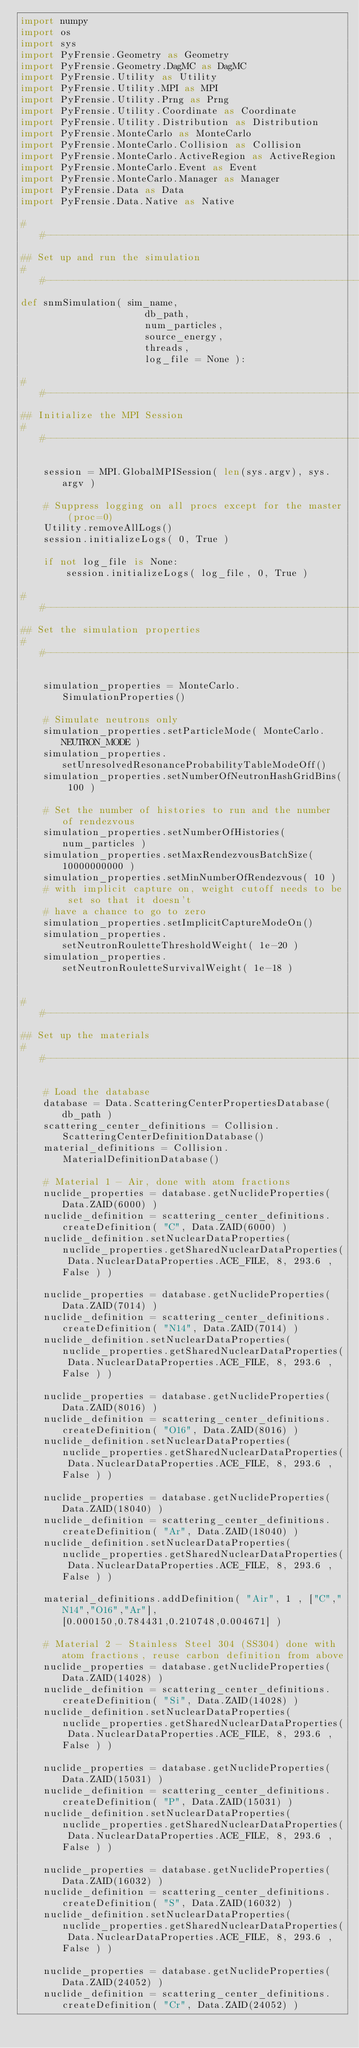<code> <loc_0><loc_0><loc_500><loc_500><_Python_>import numpy
import os
import sys
import PyFrensie.Geometry as Geometry
import PyFrensie.Geometry.DagMC as DagMC
import PyFrensie.Utility as Utility
import PyFrensie.Utility.MPI as MPI
import PyFrensie.Utility.Prng as Prng
import PyFrensie.Utility.Coordinate as Coordinate
import PyFrensie.Utility.Distribution as Distribution
import PyFrensie.MonteCarlo as MonteCarlo
import PyFrensie.MonteCarlo.Collision as Collision
import PyFrensie.MonteCarlo.ActiveRegion as ActiveRegion
import PyFrensie.MonteCarlo.Event as Event
import PyFrensie.MonteCarlo.Manager as Manager
import PyFrensie.Data as Data
import PyFrensie.Data.Native as Native

##---------------------------------------------------------------------------##
## Set up and run the simulation
##---------------------------------------------------------------------------##
def snmSimulation( sim_name,
                      db_path,
                      num_particles,
                      source_energy,
                      threads,
                      log_file = None ):
    
##---------------------------------------------------------------------------##
## Initialize the MPI Session
##---------------------------------------------------------------------------##
    
    session = MPI.GlobalMPISession( len(sys.argv), sys.argv )
    
    # Suppress logging on all procs except for the master (proc=0)
    Utility.removeAllLogs()
    session.initializeLogs( 0, True )
    
    if not log_file is None:
        session.initializeLogs( log_file, 0, True )
    
##---------------------------------------------------------------------------##
## Set the simulation properties
##---------------------------------------------------------------------------##
    
    simulation_properties = MonteCarlo.SimulationProperties()
    
    # Simulate neutrons only
    simulation_properties.setParticleMode( MonteCarlo.NEUTRON_MODE )
    simulation_properties.setUnresolvedResonanceProbabilityTableModeOff()
    simulation_properties.setNumberOfNeutronHashGridBins( 100 ) 
    
    # Set the number of histories to run and the number of rendezvous
    simulation_properties.setNumberOfHistories( num_particles )
    simulation_properties.setMaxRendezvousBatchSize( 10000000000 )
    simulation_properties.setMinNumberOfRendezvous( 10 )
    # with implicit capture on, weight cutoff needs to be set so that it doesn't 
    # have a chance to go to zero
    simulation_properties.setImplicitCaptureModeOn()
    simulation_properties.setNeutronRouletteThresholdWeight( 1e-20 )
    simulation_properties.setNeutronRouletteSurvivalWeight( 1e-18 )

    
##---------------------------------------------------------------------------##
## Set up the materials
##---------------------------------------------------------------------------##

    # Load the database
    database = Data.ScatteringCenterPropertiesDatabase( db_path )
    scattering_center_definitions = Collision.ScatteringCenterDefinitionDatabase()
    material_definitions = Collision.MaterialDefinitionDatabase()

    # Material 1 - Air, done with atom fractions
    nuclide_properties = database.getNuclideProperties( Data.ZAID(6000) )
    nuclide_definition = scattering_center_definitions.createDefinition( "C", Data.ZAID(6000) )
    nuclide_definition.setNuclearDataProperties( nuclide_properties.getSharedNuclearDataProperties( Data.NuclearDataProperties.ACE_FILE, 8, 293.6 , False ) )

    nuclide_properties = database.getNuclideProperties( Data.ZAID(7014) )
    nuclide_definition = scattering_center_definitions.createDefinition( "N14", Data.ZAID(7014) )
    nuclide_definition.setNuclearDataProperties( nuclide_properties.getSharedNuclearDataProperties( Data.NuclearDataProperties.ACE_FILE, 8, 293.6 , False ) )

    nuclide_properties = database.getNuclideProperties( Data.ZAID(8016) )
    nuclide_definition = scattering_center_definitions.createDefinition( "O16", Data.ZAID(8016) )
    nuclide_definition.setNuclearDataProperties( nuclide_properties.getSharedNuclearDataProperties( Data.NuclearDataProperties.ACE_FILE, 8, 293.6 , False ) )

    nuclide_properties = database.getNuclideProperties( Data.ZAID(18040) )
    nuclide_definition = scattering_center_definitions.createDefinition( "Ar", Data.ZAID(18040) )
    nuclide_definition.setNuclearDataProperties( nuclide_properties.getSharedNuclearDataProperties( Data.NuclearDataProperties.ACE_FILE, 8, 293.6 , False ) )

    material_definitions.addDefinition( "Air", 1 , ["C","N14","O16","Ar"], [0.000150,0.784431,0.210748,0.004671] )

    # Material 2 - Stainless Steel 304 (SS304) done with atom fractions, reuse carbon definition from above
    nuclide_properties = database.getNuclideProperties( Data.ZAID(14028) )
    nuclide_definition = scattering_center_definitions.createDefinition( "Si", Data.ZAID(14028) )
    nuclide_definition.setNuclearDataProperties( nuclide_properties.getSharedNuclearDataProperties( Data.NuclearDataProperties.ACE_FILE, 8, 293.6 , False ) )

    nuclide_properties = database.getNuclideProperties( Data.ZAID(15031) )
    nuclide_definition = scattering_center_definitions.createDefinition( "P", Data.ZAID(15031) )
    nuclide_definition.setNuclearDataProperties( nuclide_properties.getSharedNuclearDataProperties( Data.NuclearDataProperties.ACE_FILE, 8, 293.6 , False ) )

    nuclide_properties = database.getNuclideProperties( Data.ZAID(16032) )
    nuclide_definition = scattering_center_definitions.createDefinition( "S", Data.ZAID(16032) )
    nuclide_definition.setNuclearDataProperties( nuclide_properties.getSharedNuclearDataProperties( Data.NuclearDataProperties.ACE_FILE, 8, 293.6 , False ) )

    nuclide_properties = database.getNuclideProperties( Data.ZAID(24052) )
    nuclide_definition = scattering_center_definitions.createDefinition( "Cr", Data.ZAID(24052) )</code> 